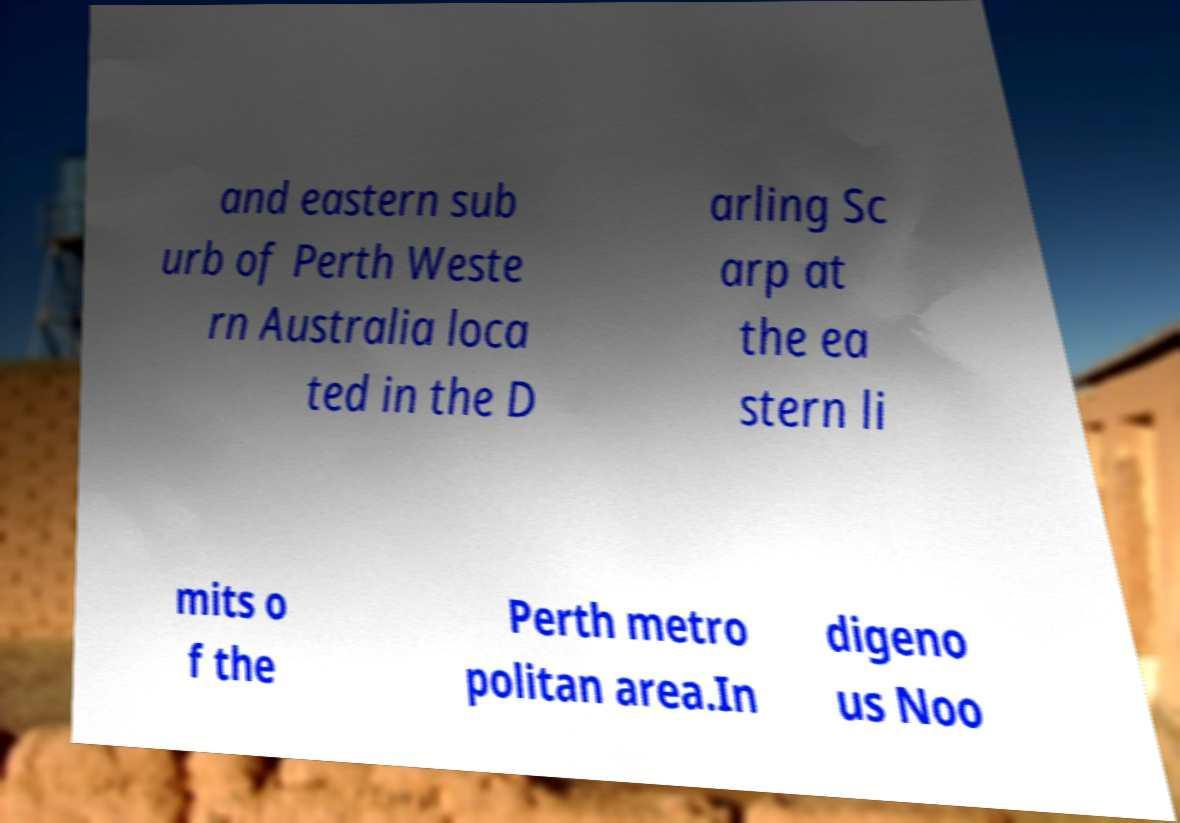There's text embedded in this image that I need extracted. Can you transcribe it verbatim? and eastern sub urb of Perth Weste rn Australia loca ted in the D arling Sc arp at the ea stern li mits o f the Perth metro politan area.In digeno us Noo 